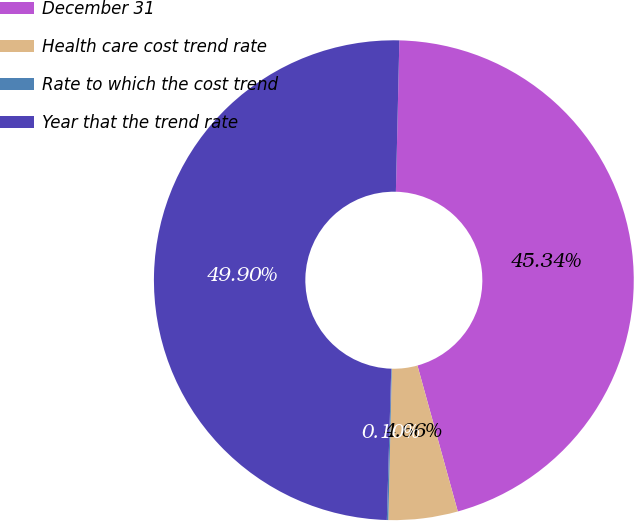Convert chart to OTSL. <chart><loc_0><loc_0><loc_500><loc_500><pie_chart><fcel>December 31<fcel>Health care cost trend rate<fcel>Rate to which the cost trend<fcel>Year that the trend rate<nl><fcel>45.34%<fcel>4.66%<fcel>0.1%<fcel>49.9%<nl></chart> 